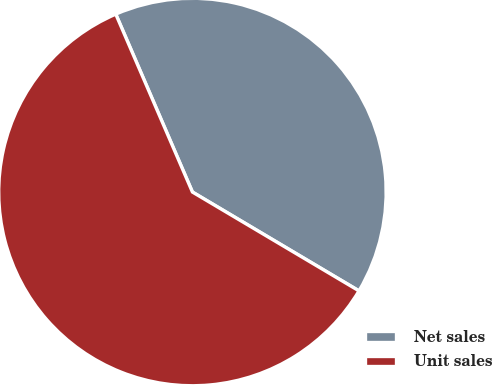<chart> <loc_0><loc_0><loc_500><loc_500><pie_chart><fcel>Net sales<fcel>Unit sales<nl><fcel>40.0%<fcel>60.0%<nl></chart> 